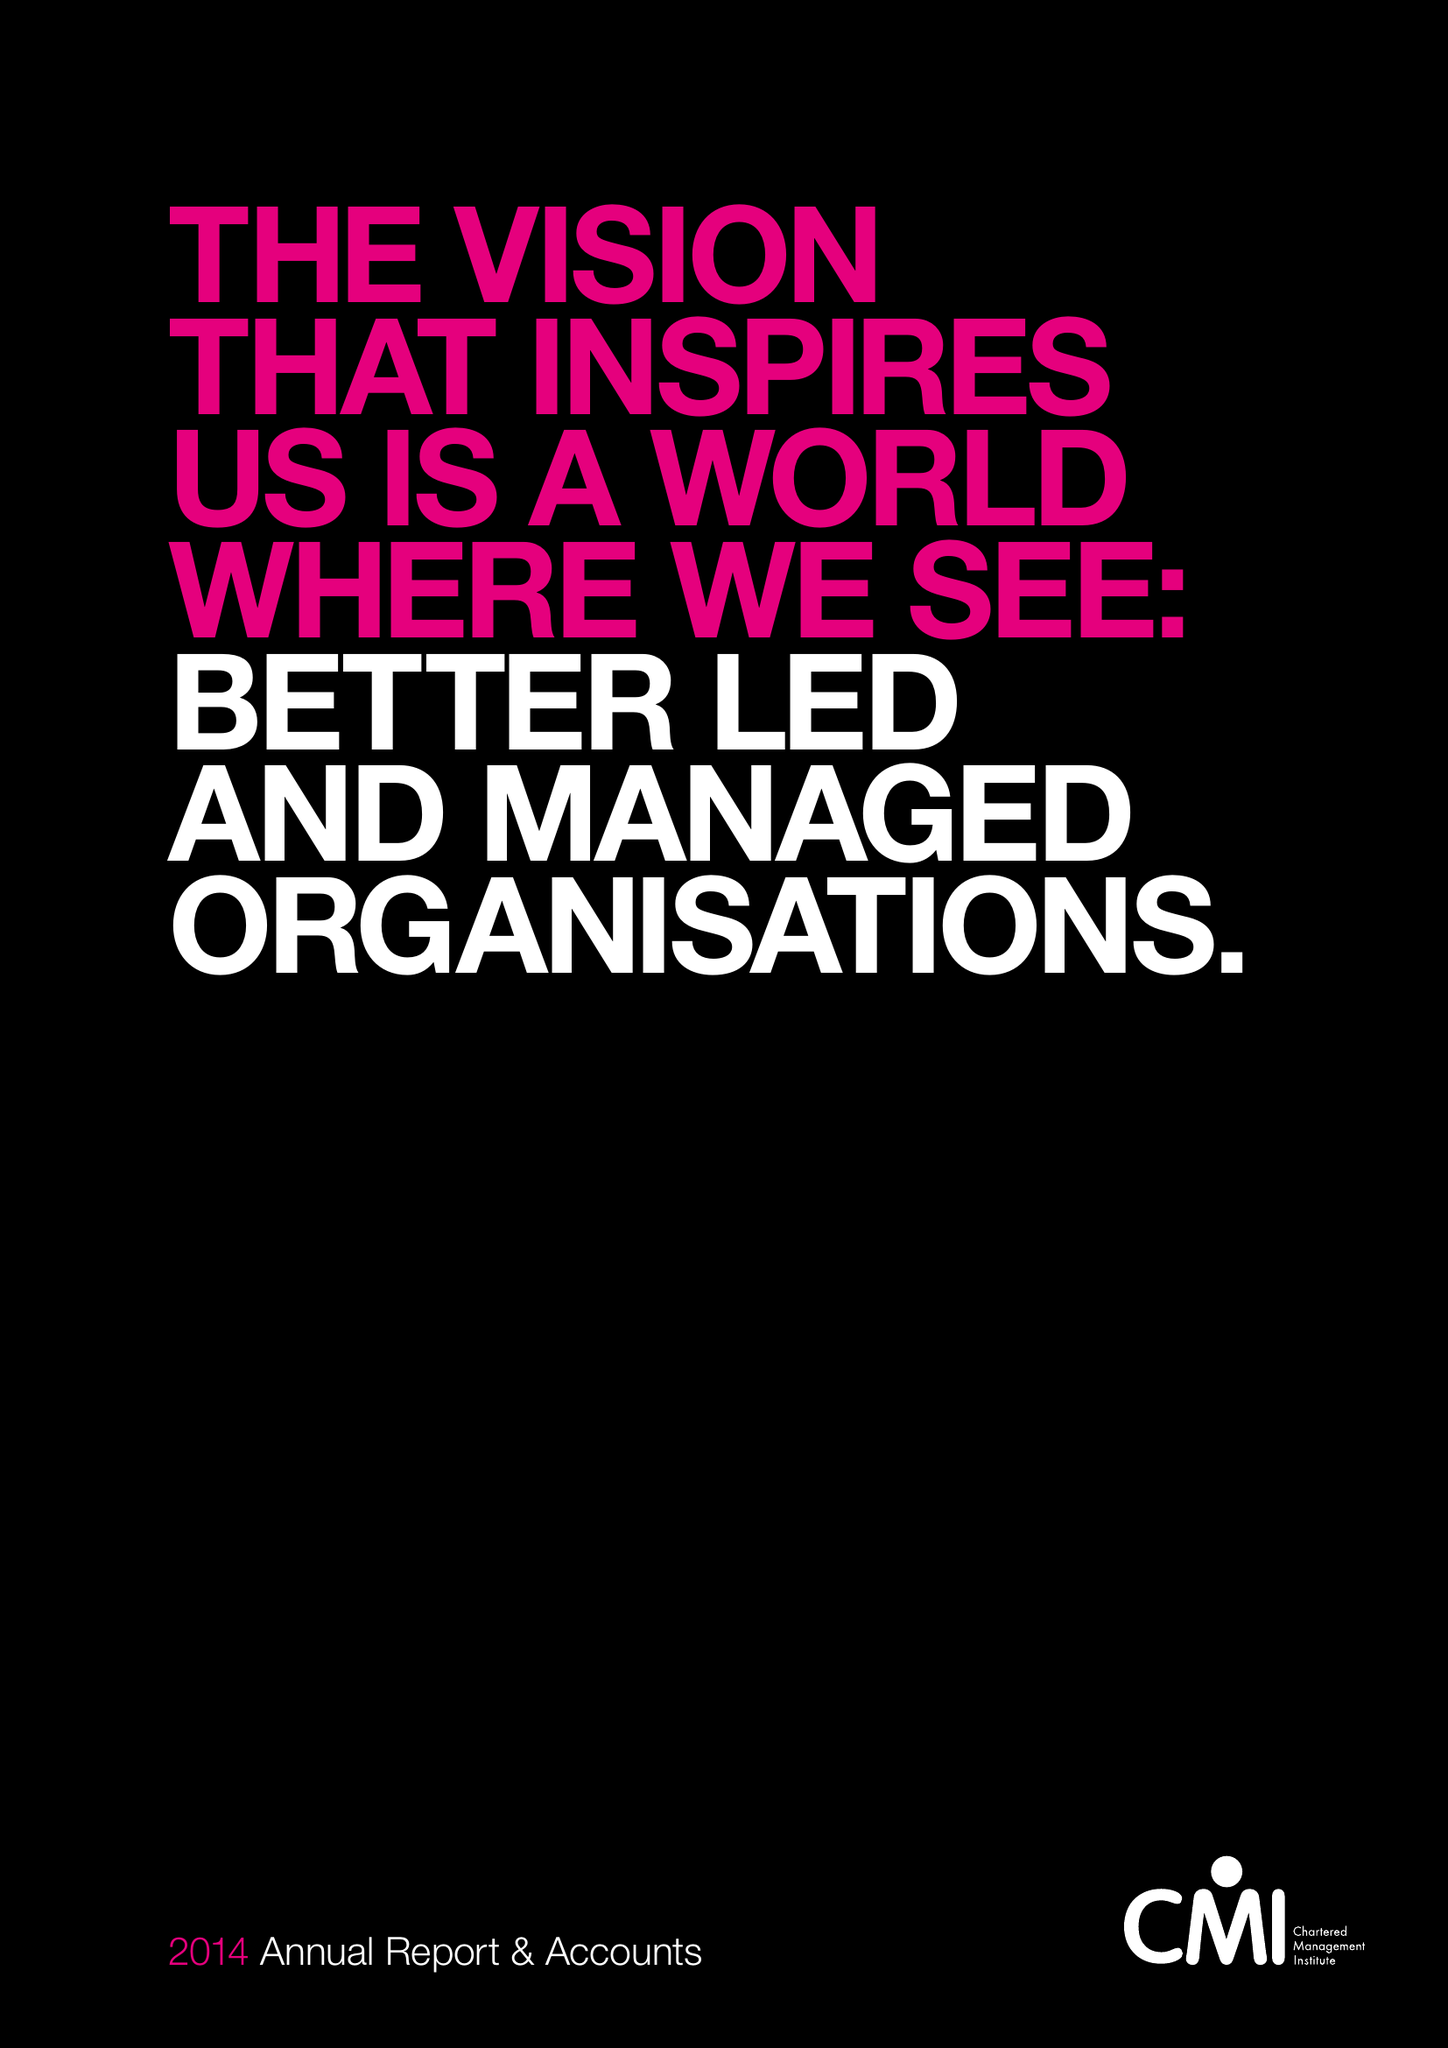What is the value for the charity_number?
Answer the question using a single word or phrase. 1091035 